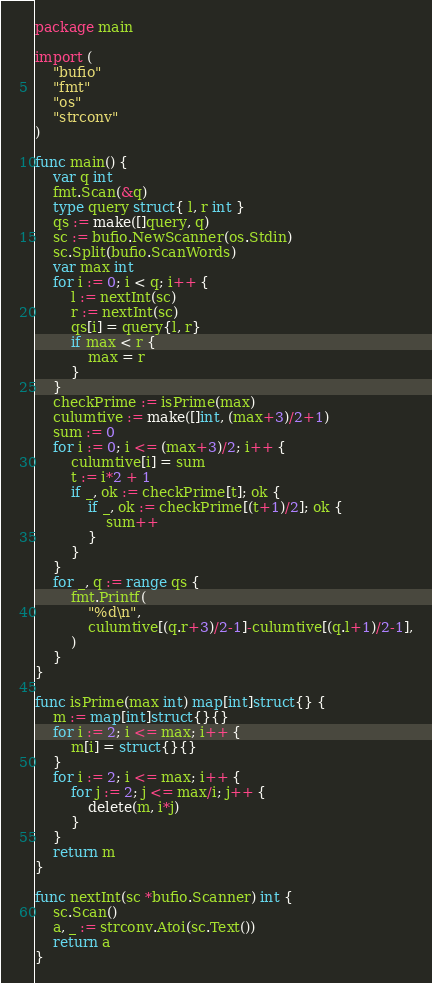<code> <loc_0><loc_0><loc_500><loc_500><_Go_>package main

import (
	"bufio"
	"fmt"
	"os"
	"strconv"
)

func main() {
	var q int
	fmt.Scan(&q)
	type query struct{ l, r int }
	qs := make([]query, q)
	sc := bufio.NewScanner(os.Stdin)
	sc.Split(bufio.ScanWords)
	var max int
	for i := 0; i < q; i++ {
		l := nextInt(sc)
		r := nextInt(sc)
		qs[i] = query{l, r}
		if max < r {
			max = r
		}
	}
	checkPrime := isPrime(max)
	culumtive := make([]int, (max+3)/2+1)
	sum := 0
	for i := 0; i <= (max+3)/2; i++ {
		culumtive[i] = sum
		t := i*2 + 1
		if _, ok := checkPrime[t]; ok {
			if _, ok := checkPrime[(t+1)/2]; ok {
				sum++
			}
		}
	}
	for _, q := range qs {
		fmt.Printf(
			"%d\n",
			culumtive[(q.r+3)/2-1]-culumtive[(q.l+1)/2-1],
		)
	}
}

func isPrime(max int) map[int]struct{} {
	m := map[int]struct{}{}
	for i := 2; i <= max; i++ {
		m[i] = struct{}{}
	}
	for i := 2; i <= max; i++ {
		for j := 2; j <= max/i; j++ {
			delete(m, i*j)
		}
	}
	return m
}

func nextInt(sc *bufio.Scanner) int {
	sc.Scan()
	a, _ := strconv.Atoi(sc.Text())
	return a
}
</code> 